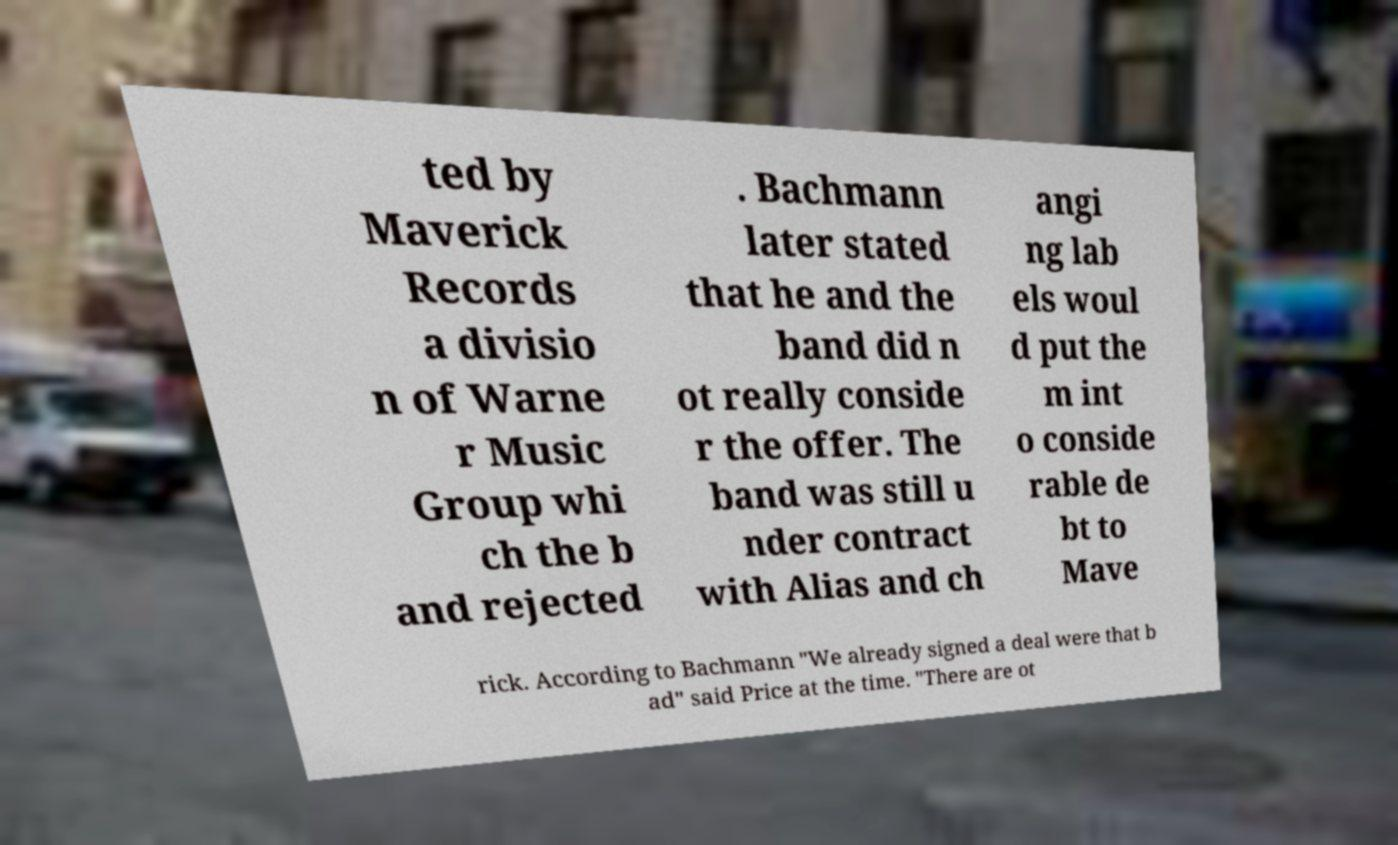Please read and relay the text visible in this image. What does it say? ted by Maverick Records a divisio n of Warne r Music Group whi ch the b and rejected . Bachmann later stated that he and the band did n ot really conside r the offer. The band was still u nder contract with Alias and ch angi ng lab els woul d put the m int o conside rable de bt to Mave rick. According to Bachmann "We already signed a deal were that b ad" said Price at the time. "There are ot 